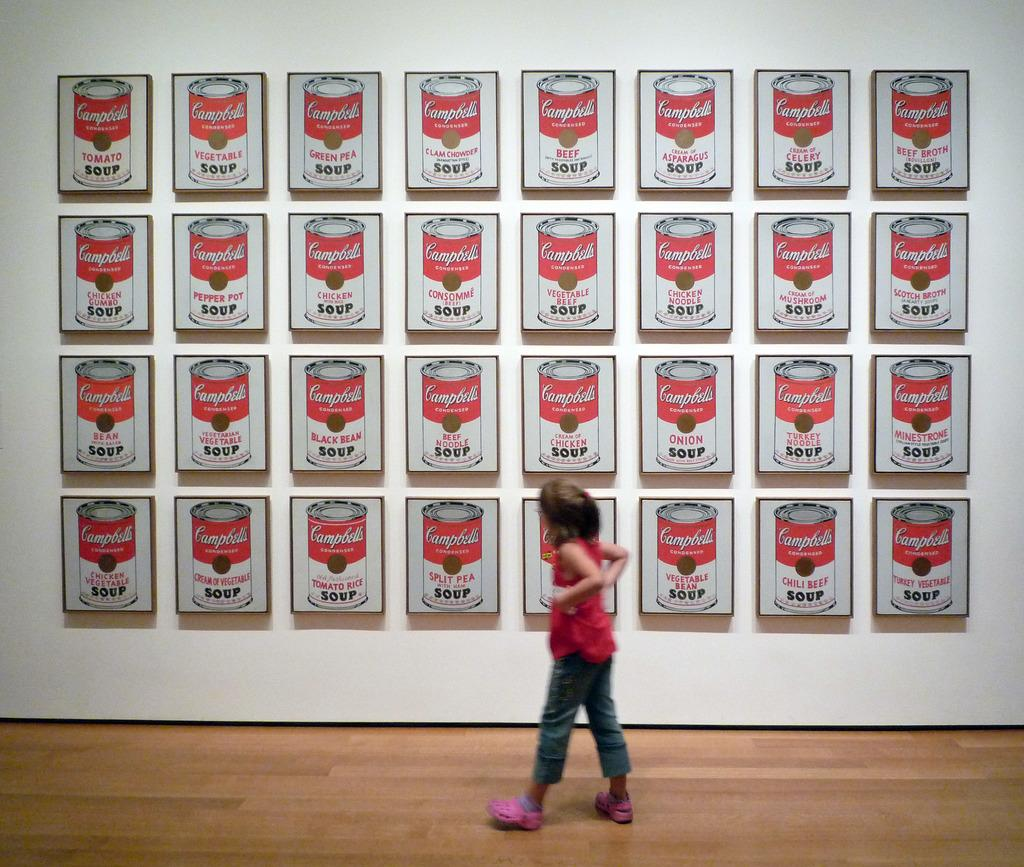Who is the main subject in the image? There is a girl in the image. What is the girl's position in the image? The girl is on the floor. What can be seen in the background of the image? There are boards on the wall in the background of the image. What type of dinner is the girl preparing in the image? There is no indication in the image that the girl is preparing dinner, as she is simply on the floor. 